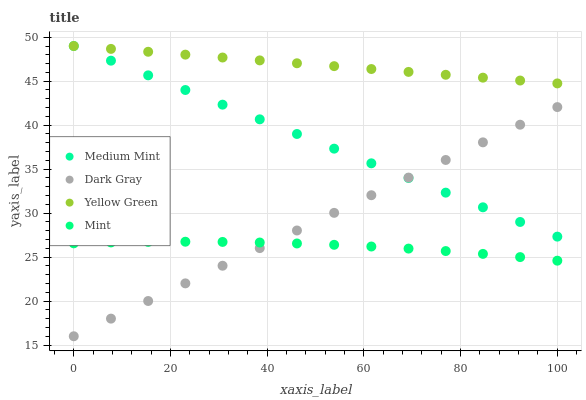Does Mint have the minimum area under the curve?
Answer yes or no. Yes. Does Yellow Green have the maximum area under the curve?
Answer yes or no. Yes. Does Dark Gray have the minimum area under the curve?
Answer yes or no. No. Does Dark Gray have the maximum area under the curve?
Answer yes or no. No. Is Dark Gray the smoothest?
Answer yes or no. Yes. Is Mint the roughest?
Answer yes or no. Yes. Is Mint the smoothest?
Answer yes or no. No. Is Dark Gray the roughest?
Answer yes or no. No. Does Dark Gray have the lowest value?
Answer yes or no. Yes. Does Mint have the lowest value?
Answer yes or no. No. Does Yellow Green have the highest value?
Answer yes or no. Yes. Does Dark Gray have the highest value?
Answer yes or no. No. Is Mint less than Yellow Green?
Answer yes or no. Yes. Is Yellow Green greater than Dark Gray?
Answer yes or no. Yes. Does Yellow Green intersect Medium Mint?
Answer yes or no. Yes. Is Yellow Green less than Medium Mint?
Answer yes or no. No. Is Yellow Green greater than Medium Mint?
Answer yes or no. No. Does Mint intersect Yellow Green?
Answer yes or no. No. 